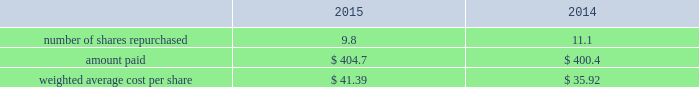Republic services , inc .
Notes to consolidated financial statements 2014 ( continued ) charges or other amounts due that are probable at settlement .
The aggregate cash surrender value of these life insurance policies was $ 90.5 million and $ 77.1 million as of december 31 , 2015 and 2014 , respectively , and is classified in other assets in our consolidated balance sheets .
The dcp liability was $ 83.3 million and $ 76.3 million as of december 31 , 2015 and 2014 , respectively , and is classified in other long-term liabilities in our consolidated balance sheets .
Employee stock purchase plan republic employees are eligible to participate in an employee stock purchase plan .
The plan allows participants to purchase our common stock for 95% ( 95 % ) of its quoted market price on the last day of each calendar quarter .
For the years ended december 31 , 2015 , 2014 and 2013 , issuances under this plan totaled 141055 shares , 139941 shares and 142217 shares , respectively .
As of december 31 , 2015 , shares reserved for issuance to employees under this plan totaled 0.6 million and republic held employee contributions of approximately $ 1.4 million for the purchase of common stock .
12 .
Stock repurchases and dividends stock repurchases stock repurchase activity during the years ended december 31 , 2015 and 2014 follows ( in millions except per share amounts ) : .
As of december 31 , 2015 , 0.1 million repurchased shares were pending settlement and $ 3.7 million were unpaid and included within our accrued liabilities .
In october 2015 , our board of directors added $ 900.0 million to the existing share repurchase authorization , which now extends through december 31 , 2017 .
Share repurchases under the program may be made through open market purchases or privately negotiated transactions in accordance with applicable federal securities laws .
While the board of directors has approved the program , the timing of any purchases , the prices and the number of shares of common stock to be purchased will be determined by our management , at its discretion , and will depend upon market conditions and other factors .
The share repurchase program may be extended , suspended or discontinued at any time .
As of december 31 , 2015 , the october 2015 repurchase program had remaining authorized purchase capacity of $ 855.5 million .
In december 2015 , our board of directors changed the status of 71272964 treasury shares to authorized and unissued .
In doing so , the number of our issued shares was reduced by the stated amount .
Our accounting policy is to deduct the par value from common stock and to reflect the excess of cost over par value as a deduction from additional paid-in capital .
The change in unissued shares resulted in a reduction of $ 2295.3 million in treasury stock , $ 0.6 million in common stock , and $ 2294.7 million in additional paid-in capital .
There was no effect on our total stockholders 2019 equity position as a result of the change .
Dividends in october 2015 , our board of directors approved a quarterly dividend of $ 0.30 per share .
Cash dividends declared were $ 404.3 million , $ 383.6 million and $ 357.3 million for the years ended december 31 , 2015 , 2014 and 2013 , respectively .
As of december 31 , 2015 , we recorded a quarterly dividend payable of $ 103.7 million to shareholders of record at the close of business on january 4 , 2016. .
What was the percentage change in the weighted average cost per share from 2014 to 2015? 
Computations: ((41.39 - 35.92) / 35.92)
Answer: 0.15228. 